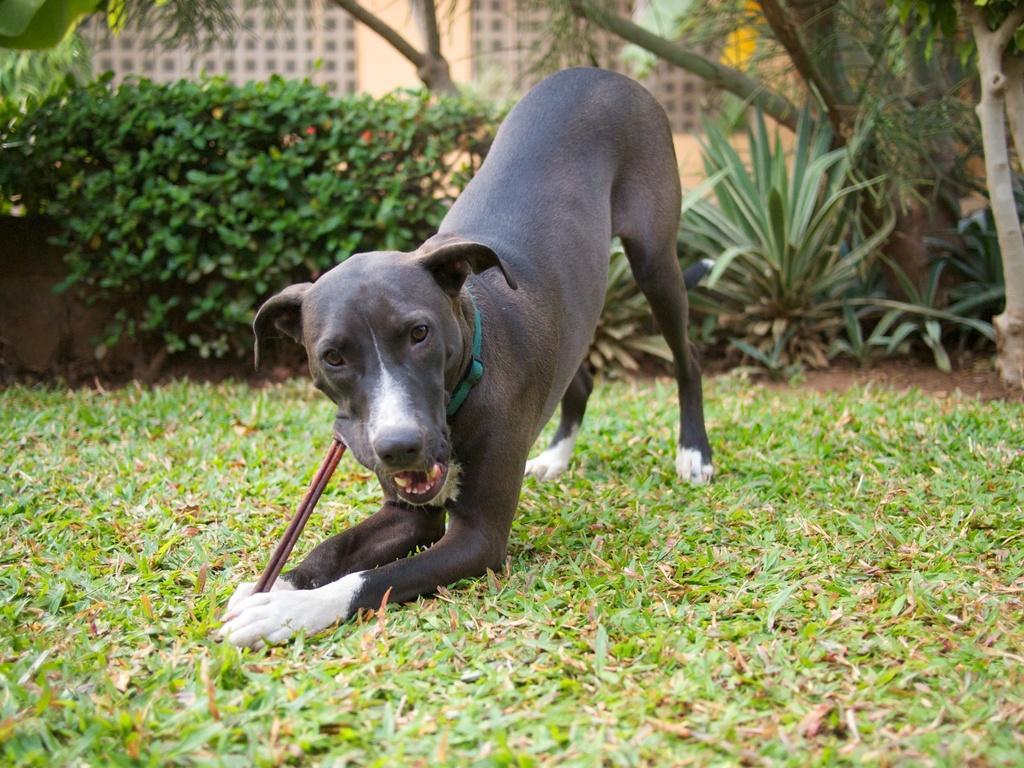Could you give a brief overview of what you see in this image? In the center of the image, we can see a dog and in the background, there are trees, plants and buildings and at the bottom, there is ground. 